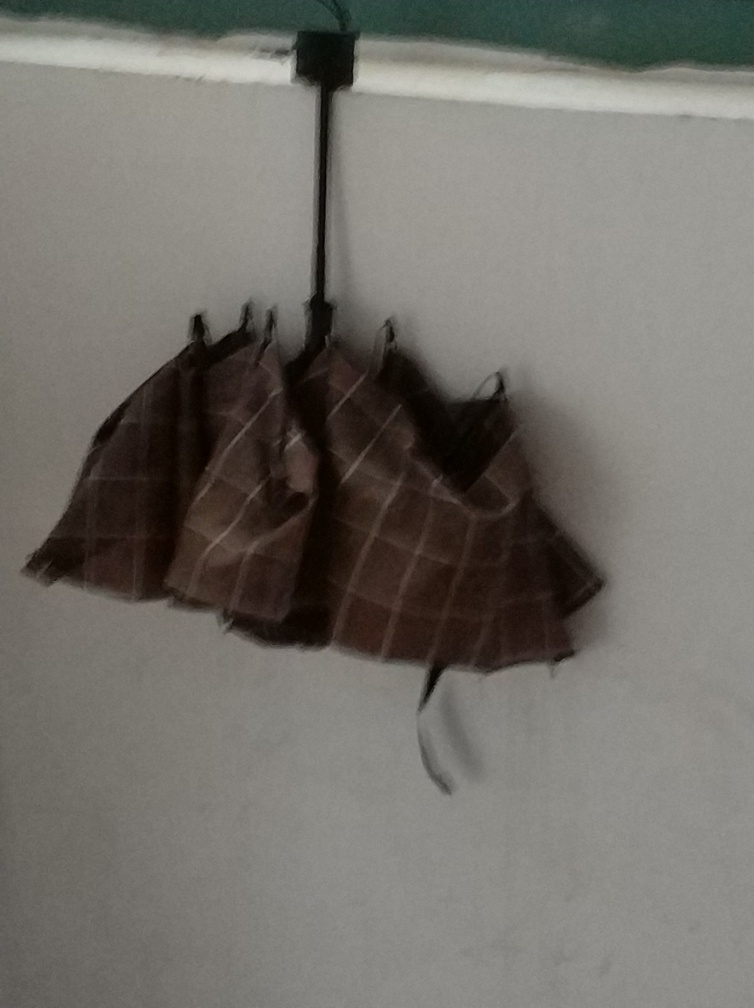How is the background wall?
A. Sharp and clear
B. Colorful and vibrant
C. Completely invisible
D. Blurry with some noise The background wall appears to be slightly blurry with a visible amount of noise which likely indicates a lower resolution or focus issue in the photograph. 